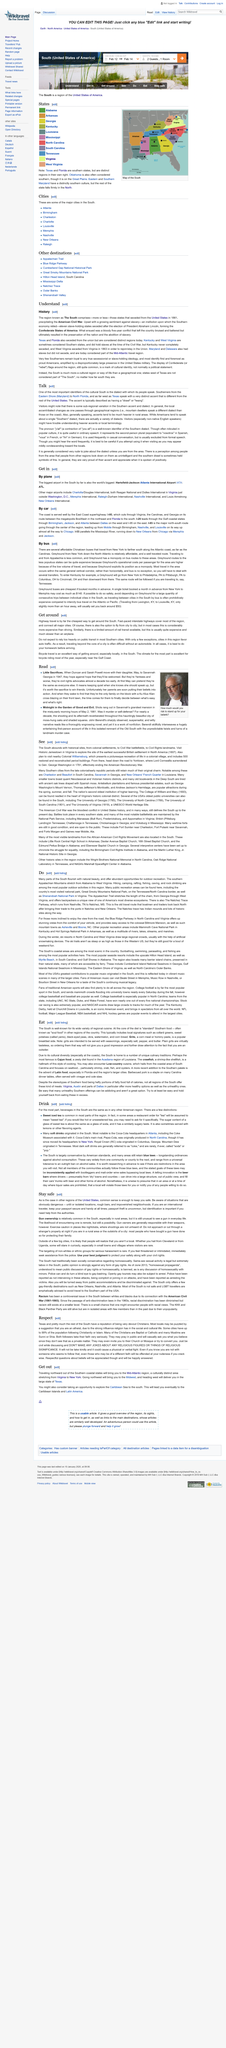Indicate a few pertinent items in this graphic. This page is focused on the subject of history. The American Civil War is specifically mentioned in the text as a historical event. This page is capable of being modified. 